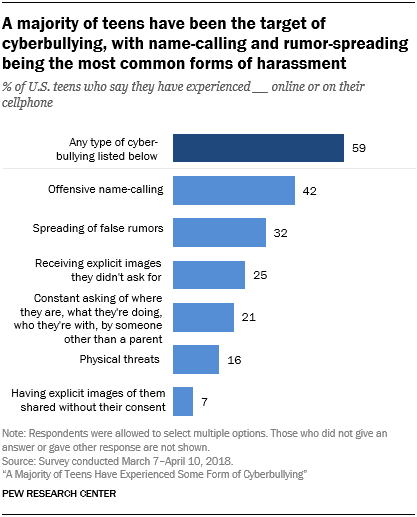Give some essential details in this illustration. The color shade of the first bar is different from that of all other bars, indicating that it may require additional attention. The average of the smallest three bar values is 14.67. 